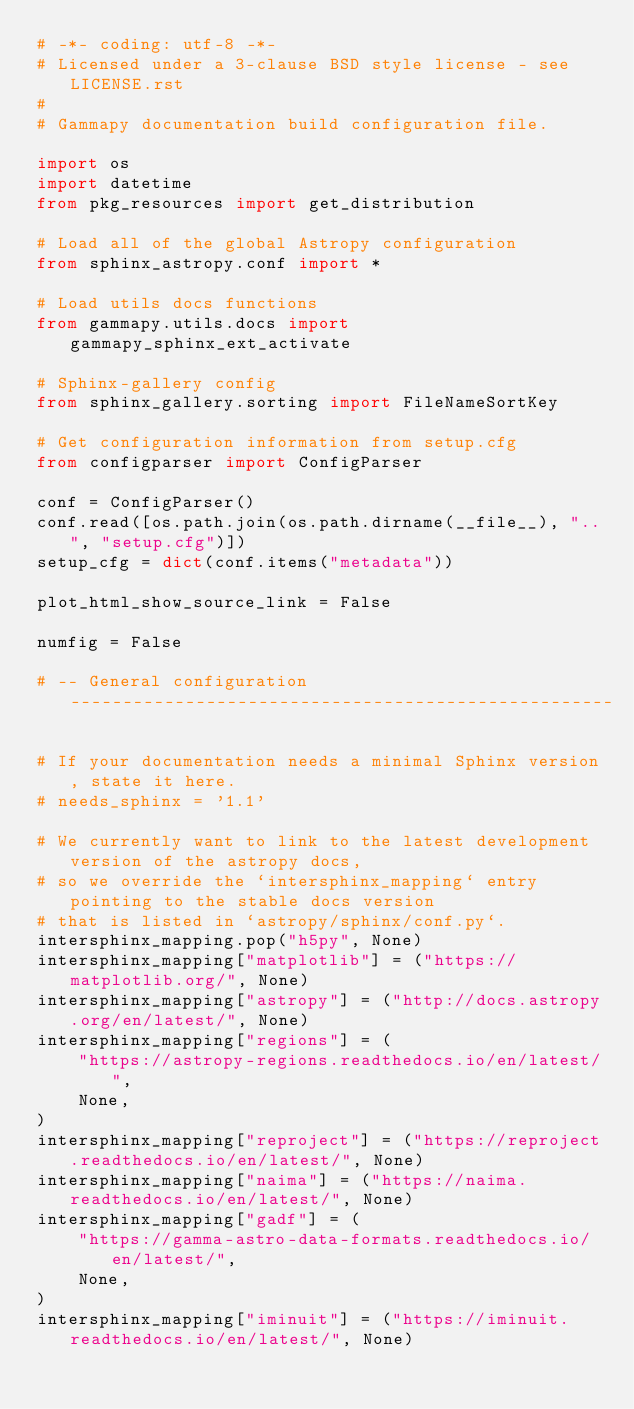<code> <loc_0><loc_0><loc_500><loc_500><_Python_># -*- coding: utf-8 -*-
# Licensed under a 3-clause BSD style license - see LICENSE.rst
#
# Gammapy documentation build configuration file.

import os
import datetime
from pkg_resources import get_distribution

# Load all of the global Astropy configuration
from sphinx_astropy.conf import *

# Load utils docs functions
from gammapy.utils.docs import gammapy_sphinx_ext_activate

# Sphinx-gallery config
from sphinx_gallery.sorting import FileNameSortKey

# Get configuration information from setup.cfg
from configparser import ConfigParser

conf = ConfigParser()
conf.read([os.path.join(os.path.dirname(__file__), "..", "setup.cfg")])
setup_cfg = dict(conf.items("metadata"))

plot_html_show_source_link = False

numfig = False

# -- General configuration ----------------------------------------------------

# If your documentation needs a minimal Sphinx version, state it here.
# needs_sphinx = '1.1'

# We currently want to link to the latest development version of the astropy docs,
# so we override the `intersphinx_mapping` entry pointing to the stable docs version
# that is listed in `astropy/sphinx/conf.py`.
intersphinx_mapping.pop("h5py", None)
intersphinx_mapping["matplotlib"] = ("https://matplotlib.org/", None)
intersphinx_mapping["astropy"] = ("http://docs.astropy.org/en/latest/", None)
intersphinx_mapping["regions"] = (
    "https://astropy-regions.readthedocs.io/en/latest/",
    None,
)
intersphinx_mapping["reproject"] = ("https://reproject.readthedocs.io/en/latest/", None)
intersphinx_mapping["naima"] = ("https://naima.readthedocs.io/en/latest/", None)
intersphinx_mapping["gadf"] = (
    "https://gamma-astro-data-formats.readthedocs.io/en/latest/",
    None,
)
intersphinx_mapping["iminuit"] = ("https://iminuit.readthedocs.io/en/latest/", None)</code> 